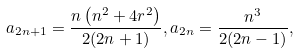<formula> <loc_0><loc_0><loc_500><loc_500>a _ { 2 n + 1 } = \frac { n \left ( n ^ { 2 } + 4 r ^ { 2 } \right ) } { 2 ( 2 n + 1 ) } , a _ { 2 n } = \frac { n ^ { 3 } } { 2 ( 2 n - 1 ) } ,</formula> 